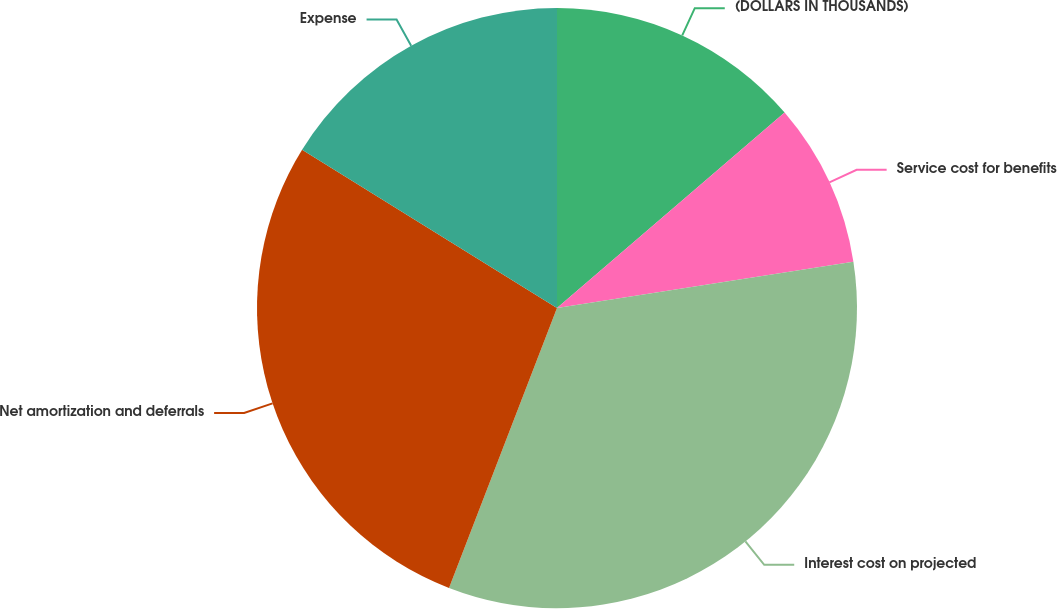<chart> <loc_0><loc_0><loc_500><loc_500><pie_chart><fcel>(DOLLARS IN THOUSANDS)<fcel>Service cost for benefits<fcel>Interest cost on projected<fcel>Net amortization and deferrals<fcel>Expense<nl><fcel>13.71%<fcel>8.82%<fcel>33.33%<fcel>27.98%<fcel>16.16%<nl></chart> 